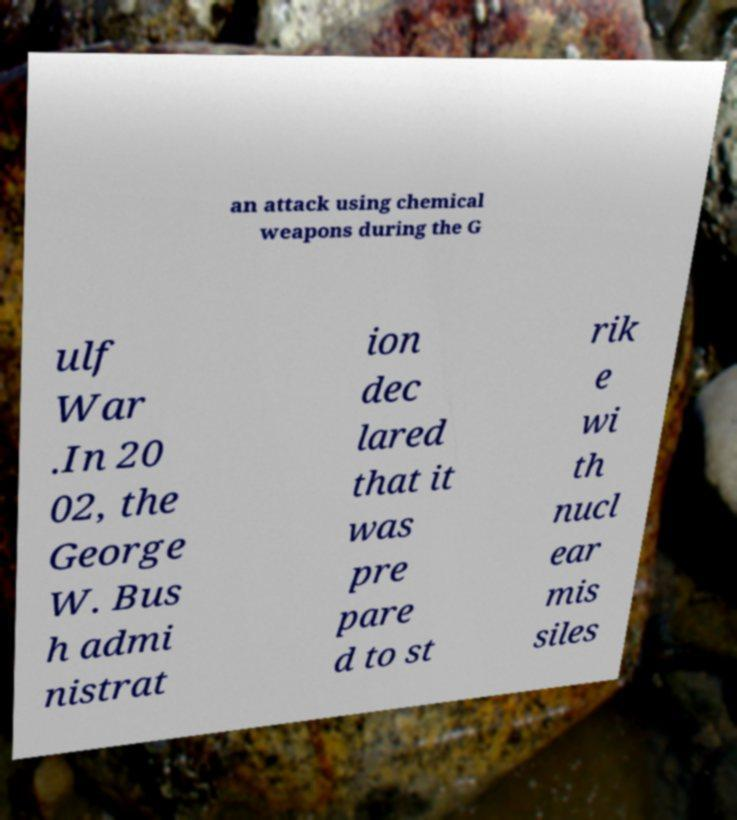For documentation purposes, I need the text within this image transcribed. Could you provide that? an attack using chemical weapons during the G ulf War .In 20 02, the George W. Bus h admi nistrat ion dec lared that it was pre pare d to st rik e wi th nucl ear mis siles 